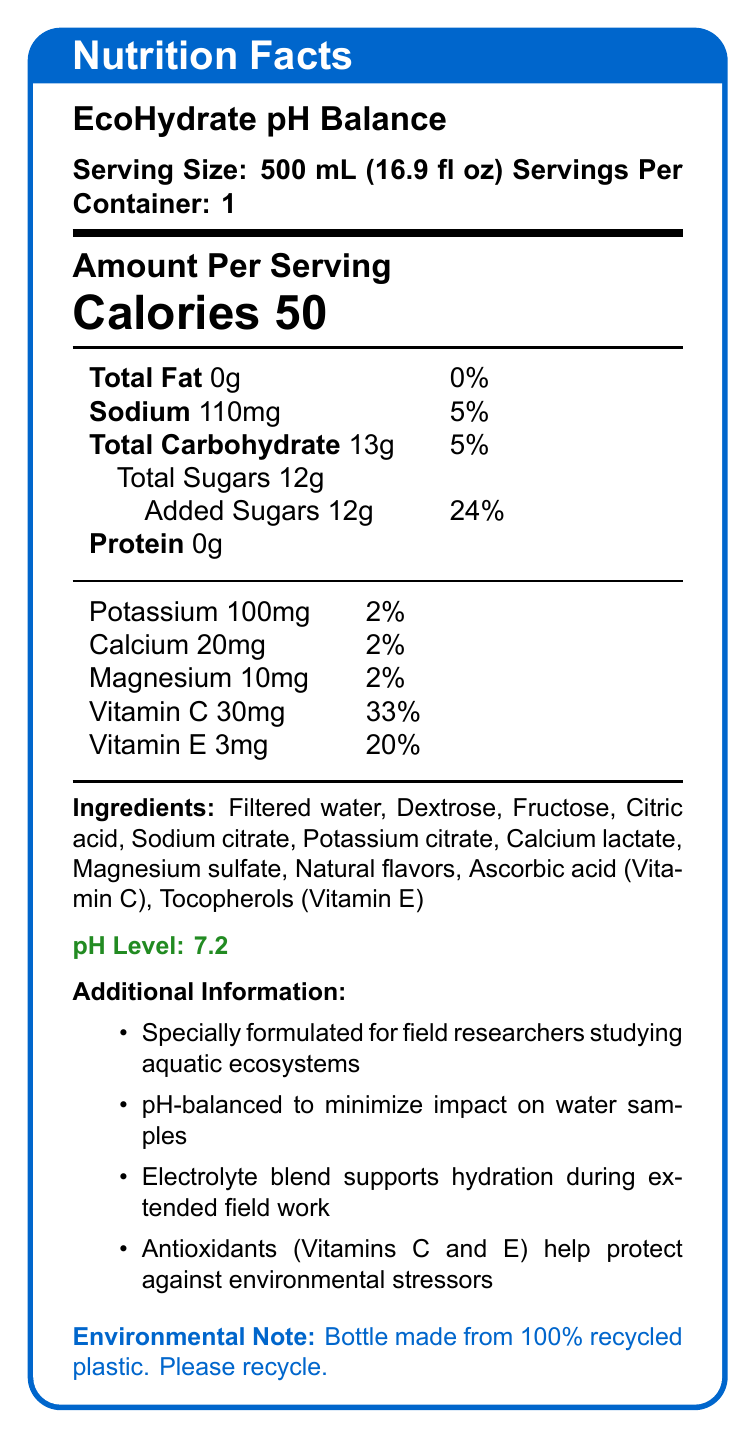what is the serving size for EcoHydrate pH Balance? The serving size is clearly stated at the beginning of the document as "Serving Size: 500 mL (16.9 fl oz)".
Answer: 500 mL (16.9 fl oz) how many calories are in one serving of EcoHydrate pH Balance? The number of calories per serving is prominently displayed in large font as "Calories 50".
Answer: 50 what is the pH level of this sports drink? The pH level is highlighted in green text as "pH Level: 7.2".
Answer: 7.2 list two electrolytes found in EcoHydrate pH Balance. The ingredients list includes "Sodium citrate, Potassium citrate" which are forms of sodium and potassium respectively.
Answer: Sodium, Potassium how much Vitamin C is in one serving of EcoHydrate pH Balance? The amount of Vitamin C is listed under the vitamins section as "Vitamin C 30mg (33%)".
Answer: 30mg how much sugar is added to EcoHydrate pH Balance? A. 10g B. 12g C. 20g D. 15g The document states "Added Sugars 12g (24%)" under total sugars.
Answer: B. 12g what is the daily value percentage of Vitamin E in this drink? A. 10% B. 20% C. 30% D. 40% The daily value percentage for Vitamin E is listed as "Vitamin E 3mg (20%)".
Answer: B. 20% is the bottle made from recycled material? The environmental note at the end states, "Bottle made from 100% recycled plastic. Please recycle."
Answer: Yes does EcoHydrate pH Balance contain protein? The nutrition facts label clearly lists "Protein 0g".
Answer: No summarize the main purpose and key features of EcoHydrate pH Balance. The document contains detailed information about the serving size, nutritional content, ingredients, pH level, and additional benefits. It emphasizes the drink's suitability for field researchers and highlights environmental considerations.
Answer: EcoHydrate pH Balance is a specially formulated sports drink designed for field researchers studying aquatic ecosystems. It is pH-balanced to minimize impact on water samples, provides hydration through an electrolyte blend, contains antioxidants like Vitamins C and E, and is low in calories. The bottle is environmentally friendly, made from 100% recycled plastic. what are the flavors used in EcoHydrate pH Balance? The document mentions "Natural flavors" as an ingredient but does not specify what these flavors are.
Answer: Not enough information what is the total carbohydrate content in one serving? The total carbohydrate content is listed as "Total Carbohydrate 13g (5%)".
Answer: 13g how does this drink minimize its impact on water samples? The document mentions that the drink is "pH-balanced to minimize impact on water samples" in the additional information section.
Answer: It is pH-balanced. which ingredient is a source of calcium? A. Magnesium sulfate B. Sodium citrate C. Calcium lactate D. Potassium citrate "Calcium lactate" is the ingredient listed that contains calcium.
Answer: C. Calcium lactate how does Vitamin C help field researchers during their work? The document states that antioxidants including Vitamin C "help protect against environmental stressors" in the additional information section.
Answer: Vitamin C helps protect against environmental stressors. 